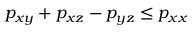<formula> <loc_0><loc_0><loc_500><loc_500>p _ { x y } + p _ { x z } - p _ { y z } \leq p _ { x x }</formula> 